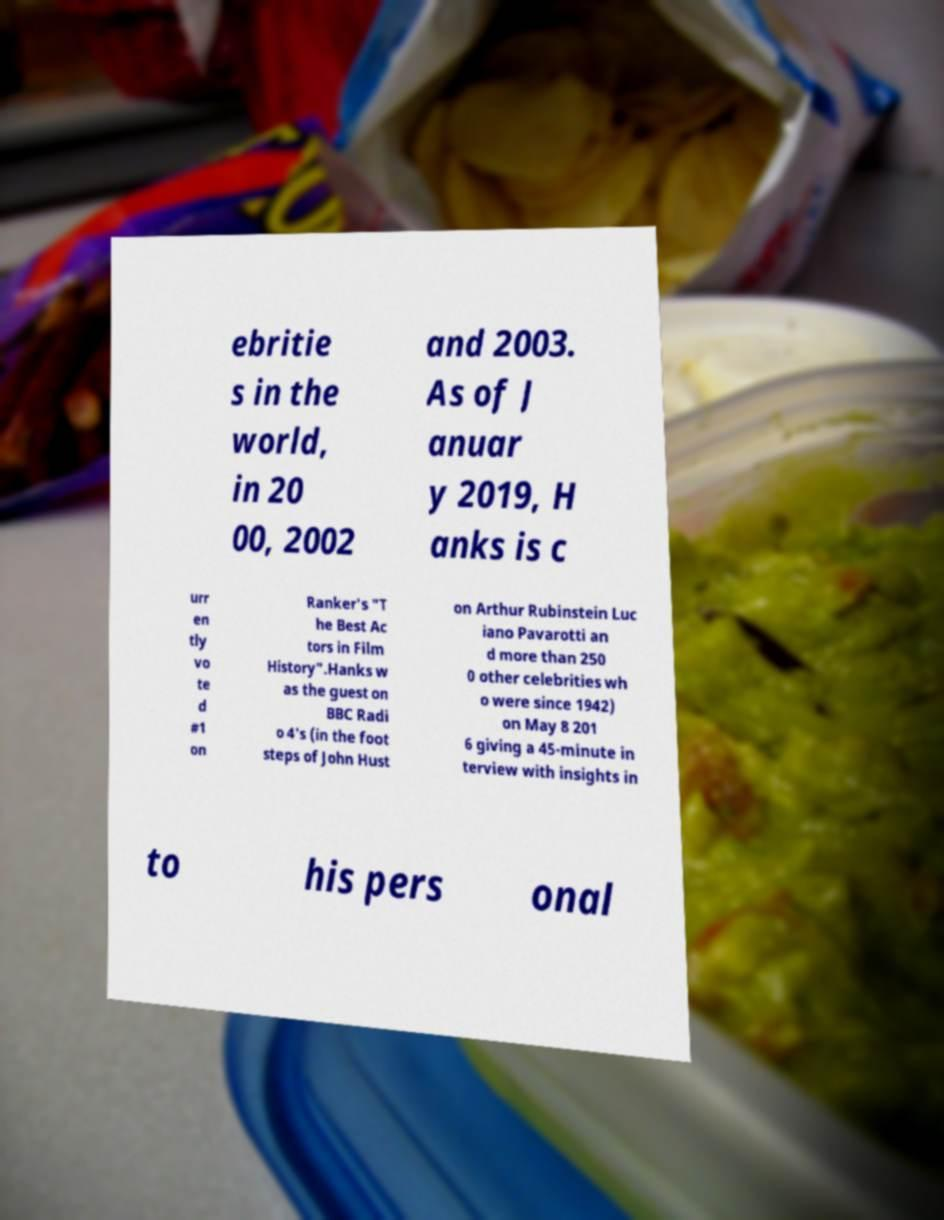Can you read and provide the text displayed in the image?This photo seems to have some interesting text. Can you extract and type it out for me? ebritie s in the world, in 20 00, 2002 and 2003. As of J anuar y 2019, H anks is c urr en tly vo te d #1 on Ranker's "T he Best Ac tors in Film History".Hanks w as the guest on BBC Radi o 4's (in the foot steps of John Hust on Arthur Rubinstein Luc iano Pavarotti an d more than 250 0 other celebrities wh o were since 1942) on May 8 201 6 giving a 45-minute in terview with insights in to his pers onal 